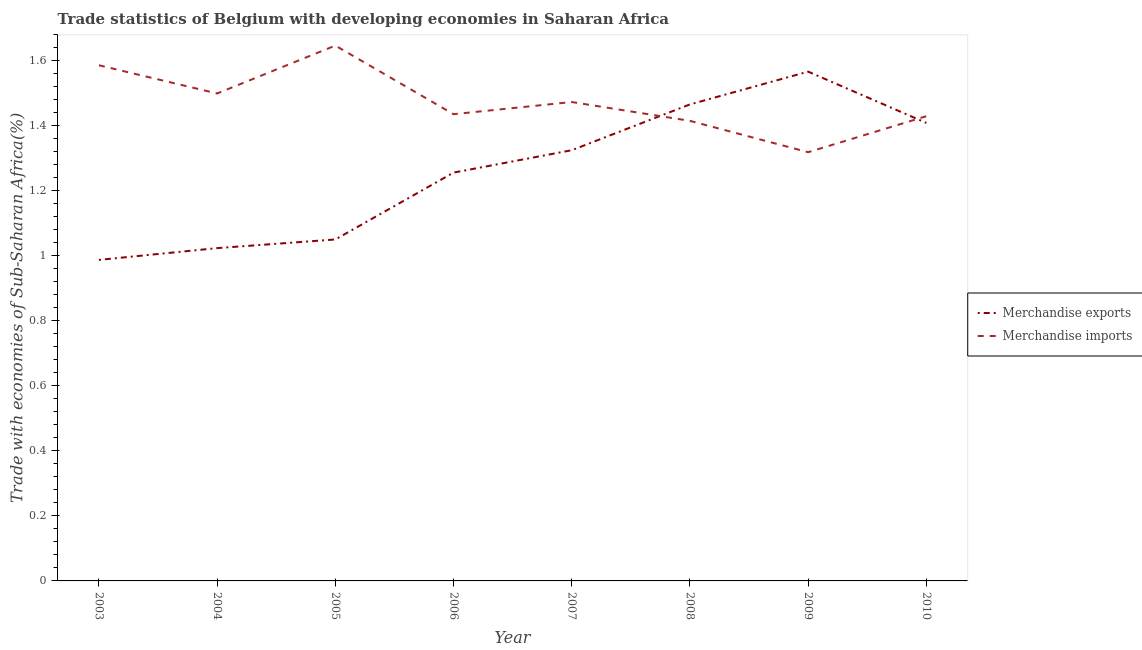How many different coloured lines are there?
Provide a succinct answer. 2. Does the line corresponding to merchandise exports intersect with the line corresponding to merchandise imports?
Provide a short and direct response. Yes. What is the merchandise imports in 2006?
Keep it short and to the point. 1.44. Across all years, what is the maximum merchandise imports?
Your answer should be compact. 1.65. Across all years, what is the minimum merchandise exports?
Offer a terse response. 0.99. In which year was the merchandise imports maximum?
Keep it short and to the point. 2005. What is the total merchandise exports in the graph?
Ensure brevity in your answer.  10.09. What is the difference between the merchandise exports in 2008 and that in 2010?
Provide a succinct answer. 0.06. What is the difference between the merchandise imports in 2003 and the merchandise exports in 2008?
Your response must be concise. 0.12. What is the average merchandise imports per year?
Your answer should be very brief. 1.48. In the year 2007, what is the difference between the merchandise imports and merchandise exports?
Ensure brevity in your answer.  0.15. In how many years, is the merchandise exports greater than 0.4 %?
Give a very brief answer. 8. What is the ratio of the merchandise imports in 2004 to that in 2005?
Make the answer very short. 0.91. Is the difference between the merchandise imports in 2003 and 2008 greater than the difference between the merchandise exports in 2003 and 2008?
Provide a short and direct response. Yes. What is the difference between the highest and the second highest merchandise imports?
Offer a terse response. 0.06. What is the difference between the highest and the lowest merchandise imports?
Your answer should be compact. 0.33. Is the sum of the merchandise imports in 2007 and 2009 greater than the maximum merchandise exports across all years?
Keep it short and to the point. Yes. Is the merchandise exports strictly greater than the merchandise imports over the years?
Your answer should be very brief. No. What is the difference between two consecutive major ticks on the Y-axis?
Ensure brevity in your answer.  0.2. Does the graph contain grids?
Keep it short and to the point. No. Where does the legend appear in the graph?
Provide a succinct answer. Center right. How many legend labels are there?
Offer a very short reply. 2. What is the title of the graph?
Your answer should be compact. Trade statistics of Belgium with developing economies in Saharan Africa. Does "Male entrants" appear as one of the legend labels in the graph?
Your answer should be compact. No. What is the label or title of the X-axis?
Make the answer very short. Year. What is the label or title of the Y-axis?
Your answer should be compact. Trade with economies of Sub-Saharan Africa(%). What is the Trade with economies of Sub-Saharan Africa(%) in Merchandise exports in 2003?
Make the answer very short. 0.99. What is the Trade with economies of Sub-Saharan Africa(%) in Merchandise imports in 2003?
Provide a succinct answer. 1.59. What is the Trade with economies of Sub-Saharan Africa(%) in Merchandise exports in 2004?
Your response must be concise. 1.02. What is the Trade with economies of Sub-Saharan Africa(%) in Merchandise imports in 2004?
Ensure brevity in your answer.  1.5. What is the Trade with economies of Sub-Saharan Africa(%) in Merchandise exports in 2005?
Give a very brief answer. 1.05. What is the Trade with economies of Sub-Saharan Africa(%) in Merchandise imports in 2005?
Ensure brevity in your answer.  1.65. What is the Trade with economies of Sub-Saharan Africa(%) of Merchandise exports in 2006?
Offer a terse response. 1.26. What is the Trade with economies of Sub-Saharan Africa(%) of Merchandise imports in 2006?
Keep it short and to the point. 1.44. What is the Trade with economies of Sub-Saharan Africa(%) of Merchandise exports in 2007?
Provide a succinct answer. 1.33. What is the Trade with economies of Sub-Saharan Africa(%) in Merchandise imports in 2007?
Provide a succinct answer. 1.47. What is the Trade with economies of Sub-Saharan Africa(%) in Merchandise exports in 2008?
Your response must be concise. 1.47. What is the Trade with economies of Sub-Saharan Africa(%) of Merchandise imports in 2008?
Provide a short and direct response. 1.42. What is the Trade with economies of Sub-Saharan Africa(%) of Merchandise exports in 2009?
Ensure brevity in your answer.  1.57. What is the Trade with economies of Sub-Saharan Africa(%) of Merchandise imports in 2009?
Give a very brief answer. 1.32. What is the Trade with economies of Sub-Saharan Africa(%) of Merchandise exports in 2010?
Keep it short and to the point. 1.41. What is the Trade with economies of Sub-Saharan Africa(%) in Merchandise imports in 2010?
Provide a succinct answer. 1.43. Across all years, what is the maximum Trade with economies of Sub-Saharan Africa(%) of Merchandise exports?
Your answer should be very brief. 1.57. Across all years, what is the maximum Trade with economies of Sub-Saharan Africa(%) in Merchandise imports?
Keep it short and to the point. 1.65. Across all years, what is the minimum Trade with economies of Sub-Saharan Africa(%) of Merchandise exports?
Give a very brief answer. 0.99. Across all years, what is the minimum Trade with economies of Sub-Saharan Africa(%) in Merchandise imports?
Offer a very short reply. 1.32. What is the total Trade with economies of Sub-Saharan Africa(%) in Merchandise exports in the graph?
Your answer should be compact. 10.09. What is the total Trade with economies of Sub-Saharan Africa(%) in Merchandise imports in the graph?
Provide a succinct answer. 11.81. What is the difference between the Trade with economies of Sub-Saharan Africa(%) in Merchandise exports in 2003 and that in 2004?
Your response must be concise. -0.04. What is the difference between the Trade with economies of Sub-Saharan Africa(%) in Merchandise imports in 2003 and that in 2004?
Your response must be concise. 0.09. What is the difference between the Trade with economies of Sub-Saharan Africa(%) in Merchandise exports in 2003 and that in 2005?
Ensure brevity in your answer.  -0.06. What is the difference between the Trade with economies of Sub-Saharan Africa(%) of Merchandise imports in 2003 and that in 2005?
Ensure brevity in your answer.  -0.06. What is the difference between the Trade with economies of Sub-Saharan Africa(%) of Merchandise exports in 2003 and that in 2006?
Offer a very short reply. -0.27. What is the difference between the Trade with economies of Sub-Saharan Africa(%) of Merchandise imports in 2003 and that in 2006?
Keep it short and to the point. 0.15. What is the difference between the Trade with economies of Sub-Saharan Africa(%) in Merchandise exports in 2003 and that in 2007?
Offer a terse response. -0.34. What is the difference between the Trade with economies of Sub-Saharan Africa(%) of Merchandise imports in 2003 and that in 2007?
Offer a very short reply. 0.11. What is the difference between the Trade with economies of Sub-Saharan Africa(%) of Merchandise exports in 2003 and that in 2008?
Your response must be concise. -0.48. What is the difference between the Trade with economies of Sub-Saharan Africa(%) in Merchandise imports in 2003 and that in 2008?
Your response must be concise. 0.17. What is the difference between the Trade with economies of Sub-Saharan Africa(%) of Merchandise exports in 2003 and that in 2009?
Provide a short and direct response. -0.58. What is the difference between the Trade with economies of Sub-Saharan Africa(%) in Merchandise imports in 2003 and that in 2009?
Your answer should be compact. 0.27. What is the difference between the Trade with economies of Sub-Saharan Africa(%) in Merchandise exports in 2003 and that in 2010?
Make the answer very short. -0.42. What is the difference between the Trade with economies of Sub-Saharan Africa(%) of Merchandise imports in 2003 and that in 2010?
Offer a terse response. 0.16. What is the difference between the Trade with economies of Sub-Saharan Africa(%) of Merchandise exports in 2004 and that in 2005?
Your answer should be very brief. -0.03. What is the difference between the Trade with economies of Sub-Saharan Africa(%) of Merchandise imports in 2004 and that in 2005?
Offer a very short reply. -0.15. What is the difference between the Trade with economies of Sub-Saharan Africa(%) of Merchandise exports in 2004 and that in 2006?
Your answer should be very brief. -0.23. What is the difference between the Trade with economies of Sub-Saharan Africa(%) of Merchandise imports in 2004 and that in 2006?
Offer a very short reply. 0.06. What is the difference between the Trade with economies of Sub-Saharan Africa(%) in Merchandise exports in 2004 and that in 2007?
Keep it short and to the point. -0.3. What is the difference between the Trade with economies of Sub-Saharan Africa(%) of Merchandise imports in 2004 and that in 2007?
Make the answer very short. 0.03. What is the difference between the Trade with economies of Sub-Saharan Africa(%) of Merchandise exports in 2004 and that in 2008?
Provide a short and direct response. -0.44. What is the difference between the Trade with economies of Sub-Saharan Africa(%) of Merchandise imports in 2004 and that in 2008?
Provide a short and direct response. 0.08. What is the difference between the Trade with economies of Sub-Saharan Africa(%) in Merchandise exports in 2004 and that in 2009?
Your response must be concise. -0.54. What is the difference between the Trade with economies of Sub-Saharan Africa(%) in Merchandise imports in 2004 and that in 2009?
Give a very brief answer. 0.18. What is the difference between the Trade with economies of Sub-Saharan Africa(%) in Merchandise exports in 2004 and that in 2010?
Offer a terse response. -0.39. What is the difference between the Trade with economies of Sub-Saharan Africa(%) of Merchandise imports in 2004 and that in 2010?
Offer a terse response. 0.07. What is the difference between the Trade with economies of Sub-Saharan Africa(%) of Merchandise exports in 2005 and that in 2006?
Keep it short and to the point. -0.21. What is the difference between the Trade with economies of Sub-Saharan Africa(%) in Merchandise imports in 2005 and that in 2006?
Your answer should be compact. 0.21. What is the difference between the Trade with economies of Sub-Saharan Africa(%) of Merchandise exports in 2005 and that in 2007?
Your response must be concise. -0.27. What is the difference between the Trade with economies of Sub-Saharan Africa(%) in Merchandise imports in 2005 and that in 2007?
Your response must be concise. 0.17. What is the difference between the Trade with economies of Sub-Saharan Africa(%) of Merchandise exports in 2005 and that in 2008?
Your response must be concise. -0.42. What is the difference between the Trade with economies of Sub-Saharan Africa(%) in Merchandise imports in 2005 and that in 2008?
Offer a terse response. 0.23. What is the difference between the Trade with economies of Sub-Saharan Africa(%) of Merchandise exports in 2005 and that in 2009?
Give a very brief answer. -0.52. What is the difference between the Trade with economies of Sub-Saharan Africa(%) in Merchandise imports in 2005 and that in 2009?
Offer a terse response. 0.33. What is the difference between the Trade with economies of Sub-Saharan Africa(%) of Merchandise exports in 2005 and that in 2010?
Offer a very short reply. -0.36. What is the difference between the Trade with economies of Sub-Saharan Africa(%) of Merchandise imports in 2005 and that in 2010?
Provide a short and direct response. 0.22. What is the difference between the Trade with economies of Sub-Saharan Africa(%) in Merchandise exports in 2006 and that in 2007?
Your response must be concise. -0.07. What is the difference between the Trade with economies of Sub-Saharan Africa(%) in Merchandise imports in 2006 and that in 2007?
Provide a short and direct response. -0.04. What is the difference between the Trade with economies of Sub-Saharan Africa(%) of Merchandise exports in 2006 and that in 2008?
Give a very brief answer. -0.21. What is the difference between the Trade with economies of Sub-Saharan Africa(%) of Merchandise imports in 2006 and that in 2008?
Give a very brief answer. 0.02. What is the difference between the Trade with economies of Sub-Saharan Africa(%) of Merchandise exports in 2006 and that in 2009?
Your answer should be very brief. -0.31. What is the difference between the Trade with economies of Sub-Saharan Africa(%) of Merchandise imports in 2006 and that in 2009?
Provide a short and direct response. 0.12. What is the difference between the Trade with economies of Sub-Saharan Africa(%) in Merchandise exports in 2006 and that in 2010?
Your answer should be very brief. -0.15. What is the difference between the Trade with economies of Sub-Saharan Africa(%) in Merchandise imports in 2006 and that in 2010?
Ensure brevity in your answer.  0.01. What is the difference between the Trade with economies of Sub-Saharan Africa(%) of Merchandise exports in 2007 and that in 2008?
Give a very brief answer. -0.14. What is the difference between the Trade with economies of Sub-Saharan Africa(%) of Merchandise imports in 2007 and that in 2008?
Offer a very short reply. 0.06. What is the difference between the Trade with economies of Sub-Saharan Africa(%) of Merchandise exports in 2007 and that in 2009?
Your response must be concise. -0.24. What is the difference between the Trade with economies of Sub-Saharan Africa(%) in Merchandise imports in 2007 and that in 2009?
Offer a very short reply. 0.15. What is the difference between the Trade with economies of Sub-Saharan Africa(%) of Merchandise exports in 2007 and that in 2010?
Offer a very short reply. -0.08. What is the difference between the Trade with economies of Sub-Saharan Africa(%) of Merchandise imports in 2007 and that in 2010?
Your answer should be very brief. 0.04. What is the difference between the Trade with economies of Sub-Saharan Africa(%) in Merchandise exports in 2008 and that in 2009?
Provide a succinct answer. -0.1. What is the difference between the Trade with economies of Sub-Saharan Africa(%) of Merchandise imports in 2008 and that in 2009?
Your answer should be very brief. 0.1. What is the difference between the Trade with economies of Sub-Saharan Africa(%) of Merchandise exports in 2008 and that in 2010?
Your response must be concise. 0.06. What is the difference between the Trade with economies of Sub-Saharan Africa(%) of Merchandise imports in 2008 and that in 2010?
Provide a short and direct response. -0.01. What is the difference between the Trade with economies of Sub-Saharan Africa(%) of Merchandise exports in 2009 and that in 2010?
Ensure brevity in your answer.  0.16. What is the difference between the Trade with economies of Sub-Saharan Africa(%) in Merchandise imports in 2009 and that in 2010?
Your answer should be very brief. -0.11. What is the difference between the Trade with economies of Sub-Saharan Africa(%) of Merchandise exports in 2003 and the Trade with economies of Sub-Saharan Africa(%) of Merchandise imports in 2004?
Your answer should be compact. -0.51. What is the difference between the Trade with economies of Sub-Saharan Africa(%) of Merchandise exports in 2003 and the Trade with economies of Sub-Saharan Africa(%) of Merchandise imports in 2005?
Your answer should be compact. -0.66. What is the difference between the Trade with economies of Sub-Saharan Africa(%) in Merchandise exports in 2003 and the Trade with economies of Sub-Saharan Africa(%) in Merchandise imports in 2006?
Make the answer very short. -0.45. What is the difference between the Trade with economies of Sub-Saharan Africa(%) in Merchandise exports in 2003 and the Trade with economies of Sub-Saharan Africa(%) in Merchandise imports in 2007?
Offer a very short reply. -0.49. What is the difference between the Trade with economies of Sub-Saharan Africa(%) of Merchandise exports in 2003 and the Trade with economies of Sub-Saharan Africa(%) of Merchandise imports in 2008?
Your answer should be very brief. -0.43. What is the difference between the Trade with economies of Sub-Saharan Africa(%) of Merchandise exports in 2003 and the Trade with economies of Sub-Saharan Africa(%) of Merchandise imports in 2009?
Provide a succinct answer. -0.33. What is the difference between the Trade with economies of Sub-Saharan Africa(%) in Merchandise exports in 2003 and the Trade with economies of Sub-Saharan Africa(%) in Merchandise imports in 2010?
Provide a succinct answer. -0.44. What is the difference between the Trade with economies of Sub-Saharan Africa(%) in Merchandise exports in 2004 and the Trade with economies of Sub-Saharan Africa(%) in Merchandise imports in 2005?
Offer a very short reply. -0.62. What is the difference between the Trade with economies of Sub-Saharan Africa(%) of Merchandise exports in 2004 and the Trade with economies of Sub-Saharan Africa(%) of Merchandise imports in 2006?
Make the answer very short. -0.41. What is the difference between the Trade with economies of Sub-Saharan Africa(%) in Merchandise exports in 2004 and the Trade with economies of Sub-Saharan Africa(%) in Merchandise imports in 2007?
Ensure brevity in your answer.  -0.45. What is the difference between the Trade with economies of Sub-Saharan Africa(%) in Merchandise exports in 2004 and the Trade with economies of Sub-Saharan Africa(%) in Merchandise imports in 2008?
Your answer should be very brief. -0.39. What is the difference between the Trade with economies of Sub-Saharan Africa(%) in Merchandise exports in 2004 and the Trade with economies of Sub-Saharan Africa(%) in Merchandise imports in 2009?
Your answer should be very brief. -0.3. What is the difference between the Trade with economies of Sub-Saharan Africa(%) in Merchandise exports in 2004 and the Trade with economies of Sub-Saharan Africa(%) in Merchandise imports in 2010?
Provide a short and direct response. -0.41. What is the difference between the Trade with economies of Sub-Saharan Africa(%) in Merchandise exports in 2005 and the Trade with economies of Sub-Saharan Africa(%) in Merchandise imports in 2006?
Your answer should be very brief. -0.39. What is the difference between the Trade with economies of Sub-Saharan Africa(%) in Merchandise exports in 2005 and the Trade with economies of Sub-Saharan Africa(%) in Merchandise imports in 2007?
Make the answer very short. -0.42. What is the difference between the Trade with economies of Sub-Saharan Africa(%) in Merchandise exports in 2005 and the Trade with economies of Sub-Saharan Africa(%) in Merchandise imports in 2008?
Offer a very short reply. -0.36. What is the difference between the Trade with economies of Sub-Saharan Africa(%) of Merchandise exports in 2005 and the Trade with economies of Sub-Saharan Africa(%) of Merchandise imports in 2009?
Ensure brevity in your answer.  -0.27. What is the difference between the Trade with economies of Sub-Saharan Africa(%) in Merchandise exports in 2005 and the Trade with economies of Sub-Saharan Africa(%) in Merchandise imports in 2010?
Provide a short and direct response. -0.38. What is the difference between the Trade with economies of Sub-Saharan Africa(%) in Merchandise exports in 2006 and the Trade with economies of Sub-Saharan Africa(%) in Merchandise imports in 2007?
Keep it short and to the point. -0.22. What is the difference between the Trade with economies of Sub-Saharan Africa(%) of Merchandise exports in 2006 and the Trade with economies of Sub-Saharan Africa(%) of Merchandise imports in 2008?
Offer a terse response. -0.16. What is the difference between the Trade with economies of Sub-Saharan Africa(%) of Merchandise exports in 2006 and the Trade with economies of Sub-Saharan Africa(%) of Merchandise imports in 2009?
Provide a succinct answer. -0.06. What is the difference between the Trade with economies of Sub-Saharan Africa(%) of Merchandise exports in 2006 and the Trade with economies of Sub-Saharan Africa(%) of Merchandise imports in 2010?
Ensure brevity in your answer.  -0.17. What is the difference between the Trade with economies of Sub-Saharan Africa(%) of Merchandise exports in 2007 and the Trade with economies of Sub-Saharan Africa(%) of Merchandise imports in 2008?
Provide a short and direct response. -0.09. What is the difference between the Trade with economies of Sub-Saharan Africa(%) in Merchandise exports in 2007 and the Trade with economies of Sub-Saharan Africa(%) in Merchandise imports in 2009?
Ensure brevity in your answer.  0.01. What is the difference between the Trade with economies of Sub-Saharan Africa(%) of Merchandise exports in 2007 and the Trade with economies of Sub-Saharan Africa(%) of Merchandise imports in 2010?
Make the answer very short. -0.1. What is the difference between the Trade with economies of Sub-Saharan Africa(%) of Merchandise exports in 2008 and the Trade with economies of Sub-Saharan Africa(%) of Merchandise imports in 2009?
Make the answer very short. 0.15. What is the difference between the Trade with economies of Sub-Saharan Africa(%) of Merchandise exports in 2008 and the Trade with economies of Sub-Saharan Africa(%) of Merchandise imports in 2010?
Ensure brevity in your answer.  0.04. What is the difference between the Trade with economies of Sub-Saharan Africa(%) of Merchandise exports in 2009 and the Trade with economies of Sub-Saharan Africa(%) of Merchandise imports in 2010?
Your answer should be compact. 0.14. What is the average Trade with economies of Sub-Saharan Africa(%) in Merchandise exports per year?
Provide a short and direct response. 1.26. What is the average Trade with economies of Sub-Saharan Africa(%) in Merchandise imports per year?
Your answer should be compact. 1.48. In the year 2003, what is the difference between the Trade with economies of Sub-Saharan Africa(%) of Merchandise exports and Trade with economies of Sub-Saharan Africa(%) of Merchandise imports?
Offer a very short reply. -0.6. In the year 2004, what is the difference between the Trade with economies of Sub-Saharan Africa(%) in Merchandise exports and Trade with economies of Sub-Saharan Africa(%) in Merchandise imports?
Provide a succinct answer. -0.48. In the year 2005, what is the difference between the Trade with economies of Sub-Saharan Africa(%) in Merchandise exports and Trade with economies of Sub-Saharan Africa(%) in Merchandise imports?
Give a very brief answer. -0.6. In the year 2006, what is the difference between the Trade with economies of Sub-Saharan Africa(%) in Merchandise exports and Trade with economies of Sub-Saharan Africa(%) in Merchandise imports?
Make the answer very short. -0.18. In the year 2007, what is the difference between the Trade with economies of Sub-Saharan Africa(%) of Merchandise exports and Trade with economies of Sub-Saharan Africa(%) of Merchandise imports?
Your answer should be very brief. -0.15. In the year 2008, what is the difference between the Trade with economies of Sub-Saharan Africa(%) in Merchandise exports and Trade with economies of Sub-Saharan Africa(%) in Merchandise imports?
Make the answer very short. 0.05. In the year 2009, what is the difference between the Trade with economies of Sub-Saharan Africa(%) in Merchandise exports and Trade with economies of Sub-Saharan Africa(%) in Merchandise imports?
Offer a very short reply. 0.25. In the year 2010, what is the difference between the Trade with economies of Sub-Saharan Africa(%) in Merchandise exports and Trade with economies of Sub-Saharan Africa(%) in Merchandise imports?
Keep it short and to the point. -0.02. What is the ratio of the Trade with economies of Sub-Saharan Africa(%) in Merchandise exports in 2003 to that in 2004?
Offer a terse response. 0.96. What is the ratio of the Trade with economies of Sub-Saharan Africa(%) of Merchandise imports in 2003 to that in 2004?
Give a very brief answer. 1.06. What is the ratio of the Trade with economies of Sub-Saharan Africa(%) of Merchandise exports in 2003 to that in 2005?
Your response must be concise. 0.94. What is the ratio of the Trade with economies of Sub-Saharan Africa(%) in Merchandise imports in 2003 to that in 2005?
Your response must be concise. 0.96. What is the ratio of the Trade with economies of Sub-Saharan Africa(%) in Merchandise exports in 2003 to that in 2006?
Your response must be concise. 0.79. What is the ratio of the Trade with economies of Sub-Saharan Africa(%) of Merchandise imports in 2003 to that in 2006?
Your response must be concise. 1.1. What is the ratio of the Trade with economies of Sub-Saharan Africa(%) in Merchandise exports in 2003 to that in 2007?
Offer a terse response. 0.75. What is the ratio of the Trade with economies of Sub-Saharan Africa(%) of Merchandise imports in 2003 to that in 2007?
Offer a very short reply. 1.08. What is the ratio of the Trade with economies of Sub-Saharan Africa(%) in Merchandise exports in 2003 to that in 2008?
Offer a very short reply. 0.67. What is the ratio of the Trade with economies of Sub-Saharan Africa(%) of Merchandise imports in 2003 to that in 2008?
Provide a succinct answer. 1.12. What is the ratio of the Trade with economies of Sub-Saharan Africa(%) of Merchandise exports in 2003 to that in 2009?
Offer a very short reply. 0.63. What is the ratio of the Trade with economies of Sub-Saharan Africa(%) of Merchandise imports in 2003 to that in 2009?
Give a very brief answer. 1.2. What is the ratio of the Trade with economies of Sub-Saharan Africa(%) in Merchandise exports in 2003 to that in 2010?
Offer a terse response. 0.7. What is the ratio of the Trade with economies of Sub-Saharan Africa(%) of Merchandise imports in 2003 to that in 2010?
Provide a succinct answer. 1.11. What is the ratio of the Trade with economies of Sub-Saharan Africa(%) of Merchandise exports in 2004 to that in 2005?
Offer a very short reply. 0.97. What is the ratio of the Trade with economies of Sub-Saharan Africa(%) of Merchandise imports in 2004 to that in 2005?
Give a very brief answer. 0.91. What is the ratio of the Trade with economies of Sub-Saharan Africa(%) in Merchandise exports in 2004 to that in 2006?
Your answer should be very brief. 0.82. What is the ratio of the Trade with economies of Sub-Saharan Africa(%) of Merchandise imports in 2004 to that in 2006?
Your response must be concise. 1.04. What is the ratio of the Trade with economies of Sub-Saharan Africa(%) in Merchandise exports in 2004 to that in 2007?
Provide a short and direct response. 0.77. What is the ratio of the Trade with economies of Sub-Saharan Africa(%) in Merchandise imports in 2004 to that in 2007?
Your answer should be very brief. 1.02. What is the ratio of the Trade with economies of Sub-Saharan Africa(%) of Merchandise exports in 2004 to that in 2008?
Offer a terse response. 0.7. What is the ratio of the Trade with economies of Sub-Saharan Africa(%) in Merchandise imports in 2004 to that in 2008?
Make the answer very short. 1.06. What is the ratio of the Trade with economies of Sub-Saharan Africa(%) in Merchandise exports in 2004 to that in 2009?
Offer a terse response. 0.65. What is the ratio of the Trade with economies of Sub-Saharan Africa(%) of Merchandise imports in 2004 to that in 2009?
Offer a very short reply. 1.14. What is the ratio of the Trade with economies of Sub-Saharan Africa(%) of Merchandise exports in 2004 to that in 2010?
Ensure brevity in your answer.  0.73. What is the ratio of the Trade with economies of Sub-Saharan Africa(%) of Merchandise imports in 2004 to that in 2010?
Offer a very short reply. 1.05. What is the ratio of the Trade with economies of Sub-Saharan Africa(%) in Merchandise exports in 2005 to that in 2006?
Offer a terse response. 0.84. What is the ratio of the Trade with economies of Sub-Saharan Africa(%) in Merchandise imports in 2005 to that in 2006?
Provide a succinct answer. 1.15. What is the ratio of the Trade with economies of Sub-Saharan Africa(%) in Merchandise exports in 2005 to that in 2007?
Your answer should be compact. 0.79. What is the ratio of the Trade with economies of Sub-Saharan Africa(%) of Merchandise imports in 2005 to that in 2007?
Keep it short and to the point. 1.12. What is the ratio of the Trade with economies of Sub-Saharan Africa(%) in Merchandise exports in 2005 to that in 2008?
Provide a short and direct response. 0.72. What is the ratio of the Trade with economies of Sub-Saharan Africa(%) of Merchandise imports in 2005 to that in 2008?
Provide a short and direct response. 1.16. What is the ratio of the Trade with economies of Sub-Saharan Africa(%) in Merchandise exports in 2005 to that in 2009?
Make the answer very short. 0.67. What is the ratio of the Trade with economies of Sub-Saharan Africa(%) of Merchandise imports in 2005 to that in 2009?
Offer a terse response. 1.25. What is the ratio of the Trade with economies of Sub-Saharan Africa(%) of Merchandise exports in 2005 to that in 2010?
Offer a terse response. 0.75. What is the ratio of the Trade with economies of Sub-Saharan Africa(%) in Merchandise imports in 2005 to that in 2010?
Give a very brief answer. 1.15. What is the ratio of the Trade with economies of Sub-Saharan Africa(%) in Merchandise exports in 2006 to that in 2007?
Offer a terse response. 0.95. What is the ratio of the Trade with economies of Sub-Saharan Africa(%) of Merchandise imports in 2006 to that in 2007?
Offer a very short reply. 0.97. What is the ratio of the Trade with economies of Sub-Saharan Africa(%) in Merchandise exports in 2006 to that in 2008?
Provide a short and direct response. 0.86. What is the ratio of the Trade with economies of Sub-Saharan Africa(%) of Merchandise imports in 2006 to that in 2008?
Your response must be concise. 1.01. What is the ratio of the Trade with economies of Sub-Saharan Africa(%) of Merchandise exports in 2006 to that in 2009?
Give a very brief answer. 0.8. What is the ratio of the Trade with economies of Sub-Saharan Africa(%) of Merchandise imports in 2006 to that in 2009?
Make the answer very short. 1.09. What is the ratio of the Trade with economies of Sub-Saharan Africa(%) in Merchandise exports in 2006 to that in 2010?
Your answer should be compact. 0.89. What is the ratio of the Trade with economies of Sub-Saharan Africa(%) in Merchandise imports in 2006 to that in 2010?
Your response must be concise. 1. What is the ratio of the Trade with economies of Sub-Saharan Africa(%) of Merchandise exports in 2007 to that in 2008?
Ensure brevity in your answer.  0.9. What is the ratio of the Trade with economies of Sub-Saharan Africa(%) of Merchandise imports in 2007 to that in 2008?
Provide a short and direct response. 1.04. What is the ratio of the Trade with economies of Sub-Saharan Africa(%) in Merchandise exports in 2007 to that in 2009?
Make the answer very short. 0.85. What is the ratio of the Trade with economies of Sub-Saharan Africa(%) of Merchandise imports in 2007 to that in 2009?
Your answer should be very brief. 1.12. What is the ratio of the Trade with economies of Sub-Saharan Africa(%) of Merchandise exports in 2007 to that in 2010?
Make the answer very short. 0.94. What is the ratio of the Trade with economies of Sub-Saharan Africa(%) in Merchandise imports in 2007 to that in 2010?
Offer a terse response. 1.03. What is the ratio of the Trade with economies of Sub-Saharan Africa(%) of Merchandise exports in 2008 to that in 2009?
Provide a short and direct response. 0.94. What is the ratio of the Trade with economies of Sub-Saharan Africa(%) of Merchandise imports in 2008 to that in 2009?
Your answer should be very brief. 1.07. What is the ratio of the Trade with economies of Sub-Saharan Africa(%) in Merchandise exports in 2008 to that in 2010?
Give a very brief answer. 1.04. What is the ratio of the Trade with economies of Sub-Saharan Africa(%) in Merchandise exports in 2009 to that in 2010?
Keep it short and to the point. 1.11. What is the ratio of the Trade with economies of Sub-Saharan Africa(%) of Merchandise imports in 2009 to that in 2010?
Provide a succinct answer. 0.92. What is the difference between the highest and the second highest Trade with economies of Sub-Saharan Africa(%) in Merchandise exports?
Keep it short and to the point. 0.1. What is the difference between the highest and the second highest Trade with economies of Sub-Saharan Africa(%) of Merchandise imports?
Give a very brief answer. 0.06. What is the difference between the highest and the lowest Trade with economies of Sub-Saharan Africa(%) of Merchandise exports?
Your answer should be compact. 0.58. What is the difference between the highest and the lowest Trade with economies of Sub-Saharan Africa(%) in Merchandise imports?
Your response must be concise. 0.33. 